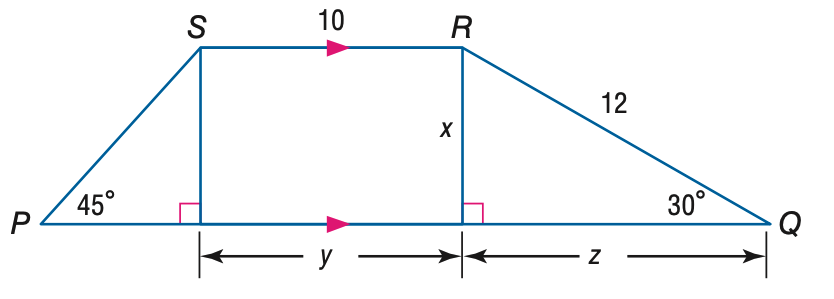Question: Find z.
Choices:
A. 2 \sqrt { 3 }
B. 6
C. 6 \sqrt { 2 }
D. 6 \sqrt { 3 }
Answer with the letter. Answer: D Question: Find y.
Choices:
A. 6
B. 8
C. 10
D. 12
Answer with the letter. Answer: C Question: Find x.
Choices:
A. 6
B. 6 \sqrt { 2 }
C. 6 \sqrt { 3 }
D. 12 \sqrt { 3 }
Answer with the letter. Answer: A Question: Find the perimeter of trapezoid P Q R S.
Choices:
A. 38
B. 38 + 6 \sqrt { 2 }
C. 38 + 6 \sqrt { 3 }
D. 38 + 6 \sqrt { 2 } + 6 \sqrt { 3 }
Answer with the letter. Answer: D 